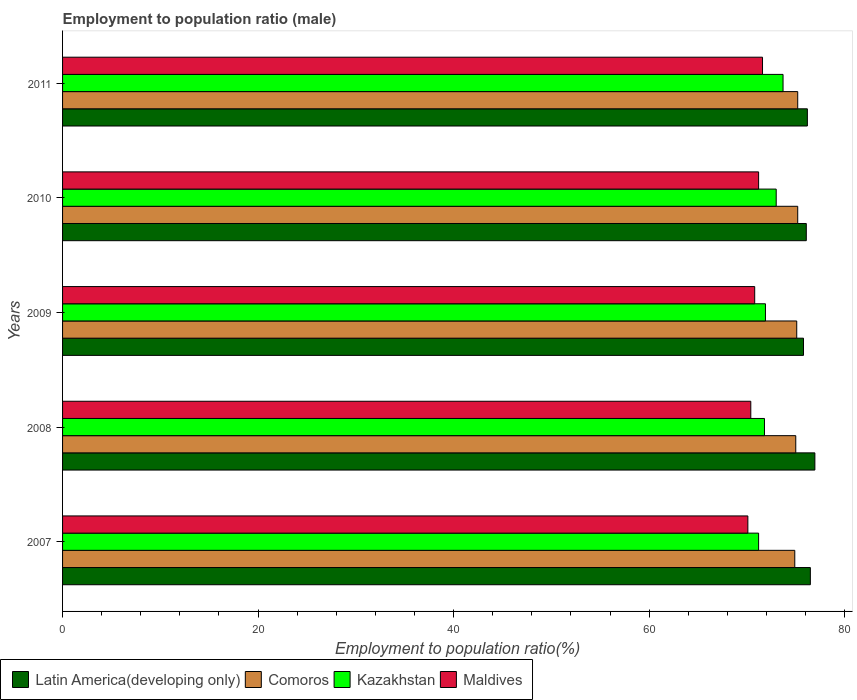How many different coloured bars are there?
Your response must be concise. 4. How many groups of bars are there?
Your response must be concise. 5. Are the number of bars per tick equal to the number of legend labels?
Provide a succinct answer. Yes. Are the number of bars on each tick of the Y-axis equal?
Provide a short and direct response. Yes. How many bars are there on the 5th tick from the top?
Provide a succinct answer. 4. What is the label of the 1st group of bars from the top?
Provide a succinct answer. 2011. In how many cases, is the number of bars for a given year not equal to the number of legend labels?
Provide a succinct answer. 0. What is the employment to population ratio in Maldives in 2008?
Offer a terse response. 70.4. Across all years, what is the maximum employment to population ratio in Kazakhstan?
Keep it short and to the point. 73.7. Across all years, what is the minimum employment to population ratio in Kazakhstan?
Make the answer very short. 71.2. In which year was the employment to population ratio in Maldives minimum?
Ensure brevity in your answer.  2007. What is the total employment to population ratio in Latin America(developing only) in the graph?
Your answer should be very brief. 381.51. What is the difference between the employment to population ratio in Comoros in 2008 and that in 2010?
Provide a short and direct response. -0.2. What is the difference between the employment to population ratio in Latin America(developing only) in 2011 and the employment to population ratio in Comoros in 2007?
Keep it short and to the point. 1.29. What is the average employment to population ratio in Kazakhstan per year?
Your response must be concise. 72.32. In the year 2009, what is the difference between the employment to population ratio in Comoros and employment to population ratio in Maldives?
Your response must be concise. 4.3. What is the ratio of the employment to population ratio in Comoros in 2008 to that in 2010?
Make the answer very short. 1. Is the difference between the employment to population ratio in Comoros in 2007 and 2009 greater than the difference between the employment to population ratio in Maldives in 2007 and 2009?
Provide a short and direct response. Yes. What is the difference between the highest and the second highest employment to population ratio in Latin America(developing only)?
Ensure brevity in your answer.  0.46. In how many years, is the employment to population ratio in Latin America(developing only) greater than the average employment to population ratio in Latin America(developing only) taken over all years?
Provide a succinct answer. 2. Is the sum of the employment to population ratio in Kazakhstan in 2008 and 2011 greater than the maximum employment to population ratio in Comoros across all years?
Your answer should be very brief. Yes. What does the 4th bar from the top in 2007 represents?
Give a very brief answer. Latin America(developing only). What does the 1st bar from the bottom in 2008 represents?
Offer a terse response. Latin America(developing only). Is it the case that in every year, the sum of the employment to population ratio in Kazakhstan and employment to population ratio in Comoros is greater than the employment to population ratio in Latin America(developing only)?
Your response must be concise. Yes. Are all the bars in the graph horizontal?
Provide a succinct answer. Yes. What is the difference between two consecutive major ticks on the X-axis?
Provide a short and direct response. 20. Are the values on the major ticks of X-axis written in scientific E-notation?
Your answer should be compact. No. Does the graph contain any zero values?
Provide a short and direct response. No. What is the title of the graph?
Provide a short and direct response. Employment to population ratio (male). Does "New Caledonia" appear as one of the legend labels in the graph?
Offer a very short reply. No. What is the label or title of the Y-axis?
Offer a terse response. Years. What is the Employment to population ratio(%) of Latin America(developing only) in 2007?
Your answer should be compact. 76.49. What is the Employment to population ratio(%) of Comoros in 2007?
Offer a very short reply. 74.9. What is the Employment to population ratio(%) in Kazakhstan in 2007?
Make the answer very short. 71.2. What is the Employment to population ratio(%) in Maldives in 2007?
Keep it short and to the point. 70.1. What is the Employment to population ratio(%) in Latin America(developing only) in 2008?
Ensure brevity in your answer.  76.96. What is the Employment to population ratio(%) of Comoros in 2008?
Offer a very short reply. 75. What is the Employment to population ratio(%) of Kazakhstan in 2008?
Offer a very short reply. 71.8. What is the Employment to population ratio(%) of Maldives in 2008?
Give a very brief answer. 70.4. What is the Employment to population ratio(%) in Latin America(developing only) in 2009?
Your response must be concise. 75.79. What is the Employment to population ratio(%) in Comoros in 2009?
Give a very brief answer. 75.1. What is the Employment to population ratio(%) of Kazakhstan in 2009?
Your response must be concise. 71.9. What is the Employment to population ratio(%) of Maldives in 2009?
Keep it short and to the point. 70.8. What is the Employment to population ratio(%) of Latin America(developing only) in 2010?
Provide a short and direct response. 76.08. What is the Employment to population ratio(%) in Comoros in 2010?
Offer a very short reply. 75.2. What is the Employment to population ratio(%) in Kazakhstan in 2010?
Your answer should be compact. 73. What is the Employment to population ratio(%) in Maldives in 2010?
Ensure brevity in your answer.  71.2. What is the Employment to population ratio(%) of Latin America(developing only) in 2011?
Provide a succinct answer. 76.19. What is the Employment to population ratio(%) of Comoros in 2011?
Your answer should be compact. 75.2. What is the Employment to population ratio(%) of Kazakhstan in 2011?
Make the answer very short. 73.7. What is the Employment to population ratio(%) of Maldives in 2011?
Offer a terse response. 71.6. Across all years, what is the maximum Employment to population ratio(%) in Latin America(developing only)?
Offer a terse response. 76.96. Across all years, what is the maximum Employment to population ratio(%) of Comoros?
Ensure brevity in your answer.  75.2. Across all years, what is the maximum Employment to population ratio(%) of Kazakhstan?
Keep it short and to the point. 73.7. Across all years, what is the maximum Employment to population ratio(%) of Maldives?
Make the answer very short. 71.6. Across all years, what is the minimum Employment to population ratio(%) in Latin America(developing only)?
Keep it short and to the point. 75.79. Across all years, what is the minimum Employment to population ratio(%) of Comoros?
Offer a terse response. 74.9. Across all years, what is the minimum Employment to population ratio(%) of Kazakhstan?
Your answer should be very brief. 71.2. Across all years, what is the minimum Employment to population ratio(%) in Maldives?
Your response must be concise. 70.1. What is the total Employment to population ratio(%) in Latin America(developing only) in the graph?
Your answer should be very brief. 381.51. What is the total Employment to population ratio(%) of Comoros in the graph?
Offer a very short reply. 375.4. What is the total Employment to population ratio(%) in Kazakhstan in the graph?
Give a very brief answer. 361.6. What is the total Employment to population ratio(%) in Maldives in the graph?
Make the answer very short. 354.1. What is the difference between the Employment to population ratio(%) of Latin America(developing only) in 2007 and that in 2008?
Provide a succinct answer. -0.46. What is the difference between the Employment to population ratio(%) of Comoros in 2007 and that in 2008?
Your answer should be compact. -0.1. What is the difference between the Employment to population ratio(%) in Maldives in 2007 and that in 2008?
Your answer should be compact. -0.3. What is the difference between the Employment to population ratio(%) of Latin America(developing only) in 2007 and that in 2009?
Your response must be concise. 0.7. What is the difference between the Employment to population ratio(%) of Kazakhstan in 2007 and that in 2009?
Ensure brevity in your answer.  -0.7. What is the difference between the Employment to population ratio(%) of Maldives in 2007 and that in 2009?
Your response must be concise. -0.7. What is the difference between the Employment to population ratio(%) in Latin America(developing only) in 2007 and that in 2010?
Your answer should be compact. 0.41. What is the difference between the Employment to population ratio(%) in Kazakhstan in 2007 and that in 2010?
Provide a succinct answer. -1.8. What is the difference between the Employment to population ratio(%) in Latin America(developing only) in 2007 and that in 2011?
Your response must be concise. 0.3. What is the difference between the Employment to population ratio(%) of Kazakhstan in 2007 and that in 2011?
Ensure brevity in your answer.  -2.5. What is the difference between the Employment to population ratio(%) in Maldives in 2007 and that in 2011?
Keep it short and to the point. -1.5. What is the difference between the Employment to population ratio(%) in Latin America(developing only) in 2008 and that in 2009?
Keep it short and to the point. 1.16. What is the difference between the Employment to population ratio(%) in Kazakhstan in 2008 and that in 2009?
Offer a very short reply. -0.1. What is the difference between the Employment to population ratio(%) of Latin America(developing only) in 2008 and that in 2010?
Make the answer very short. 0.88. What is the difference between the Employment to population ratio(%) of Maldives in 2008 and that in 2010?
Provide a succinct answer. -0.8. What is the difference between the Employment to population ratio(%) of Latin America(developing only) in 2008 and that in 2011?
Provide a short and direct response. 0.77. What is the difference between the Employment to population ratio(%) in Comoros in 2008 and that in 2011?
Offer a very short reply. -0.2. What is the difference between the Employment to population ratio(%) of Kazakhstan in 2008 and that in 2011?
Provide a short and direct response. -1.9. What is the difference between the Employment to population ratio(%) in Maldives in 2008 and that in 2011?
Provide a succinct answer. -1.2. What is the difference between the Employment to population ratio(%) of Latin America(developing only) in 2009 and that in 2010?
Your response must be concise. -0.29. What is the difference between the Employment to population ratio(%) of Latin America(developing only) in 2009 and that in 2011?
Offer a very short reply. -0.4. What is the difference between the Employment to population ratio(%) in Comoros in 2009 and that in 2011?
Keep it short and to the point. -0.1. What is the difference between the Employment to population ratio(%) of Kazakhstan in 2009 and that in 2011?
Your response must be concise. -1.8. What is the difference between the Employment to population ratio(%) of Latin America(developing only) in 2010 and that in 2011?
Your answer should be very brief. -0.11. What is the difference between the Employment to population ratio(%) in Latin America(developing only) in 2007 and the Employment to population ratio(%) in Comoros in 2008?
Offer a very short reply. 1.49. What is the difference between the Employment to population ratio(%) in Latin America(developing only) in 2007 and the Employment to population ratio(%) in Kazakhstan in 2008?
Provide a succinct answer. 4.69. What is the difference between the Employment to population ratio(%) of Latin America(developing only) in 2007 and the Employment to population ratio(%) of Maldives in 2008?
Offer a terse response. 6.09. What is the difference between the Employment to population ratio(%) in Comoros in 2007 and the Employment to population ratio(%) in Kazakhstan in 2008?
Give a very brief answer. 3.1. What is the difference between the Employment to population ratio(%) of Comoros in 2007 and the Employment to population ratio(%) of Maldives in 2008?
Provide a short and direct response. 4.5. What is the difference between the Employment to population ratio(%) of Latin America(developing only) in 2007 and the Employment to population ratio(%) of Comoros in 2009?
Offer a very short reply. 1.39. What is the difference between the Employment to population ratio(%) in Latin America(developing only) in 2007 and the Employment to population ratio(%) in Kazakhstan in 2009?
Your response must be concise. 4.59. What is the difference between the Employment to population ratio(%) in Latin America(developing only) in 2007 and the Employment to population ratio(%) in Maldives in 2009?
Offer a terse response. 5.69. What is the difference between the Employment to population ratio(%) in Comoros in 2007 and the Employment to population ratio(%) in Maldives in 2009?
Your answer should be very brief. 4.1. What is the difference between the Employment to population ratio(%) of Latin America(developing only) in 2007 and the Employment to population ratio(%) of Comoros in 2010?
Offer a very short reply. 1.29. What is the difference between the Employment to population ratio(%) in Latin America(developing only) in 2007 and the Employment to population ratio(%) in Kazakhstan in 2010?
Your answer should be very brief. 3.49. What is the difference between the Employment to population ratio(%) of Latin America(developing only) in 2007 and the Employment to population ratio(%) of Maldives in 2010?
Give a very brief answer. 5.29. What is the difference between the Employment to population ratio(%) in Kazakhstan in 2007 and the Employment to population ratio(%) in Maldives in 2010?
Offer a terse response. 0. What is the difference between the Employment to population ratio(%) in Latin America(developing only) in 2007 and the Employment to population ratio(%) in Comoros in 2011?
Make the answer very short. 1.29. What is the difference between the Employment to population ratio(%) in Latin America(developing only) in 2007 and the Employment to population ratio(%) in Kazakhstan in 2011?
Ensure brevity in your answer.  2.79. What is the difference between the Employment to population ratio(%) in Latin America(developing only) in 2007 and the Employment to population ratio(%) in Maldives in 2011?
Make the answer very short. 4.89. What is the difference between the Employment to population ratio(%) in Kazakhstan in 2007 and the Employment to population ratio(%) in Maldives in 2011?
Ensure brevity in your answer.  -0.4. What is the difference between the Employment to population ratio(%) in Latin America(developing only) in 2008 and the Employment to population ratio(%) in Comoros in 2009?
Keep it short and to the point. 1.86. What is the difference between the Employment to population ratio(%) in Latin America(developing only) in 2008 and the Employment to population ratio(%) in Kazakhstan in 2009?
Your answer should be compact. 5.06. What is the difference between the Employment to population ratio(%) of Latin America(developing only) in 2008 and the Employment to population ratio(%) of Maldives in 2009?
Offer a very short reply. 6.16. What is the difference between the Employment to population ratio(%) of Comoros in 2008 and the Employment to population ratio(%) of Kazakhstan in 2009?
Offer a very short reply. 3.1. What is the difference between the Employment to population ratio(%) of Kazakhstan in 2008 and the Employment to population ratio(%) of Maldives in 2009?
Provide a succinct answer. 1. What is the difference between the Employment to population ratio(%) of Latin America(developing only) in 2008 and the Employment to population ratio(%) of Comoros in 2010?
Provide a short and direct response. 1.76. What is the difference between the Employment to population ratio(%) of Latin America(developing only) in 2008 and the Employment to population ratio(%) of Kazakhstan in 2010?
Your response must be concise. 3.96. What is the difference between the Employment to population ratio(%) of Latin America(developing only) in 2008 and the Employment to population ratio(%) of Maldives in 2010?
Offer a terse response. 5.76. What is the difference between the Employment to population ratio(%) of Comoros in 2008 and the Employment to population ratio(%) of Maldives in 2010?
Ensure brevity in your answer.  3.8. What is the difference between the Employment to population ratio(%) in Latin America(developing only) in 2008 and the Employment to population ratio(%) in Comoros in 2011?
Offer a very short reply. 1.76. What is the difference between the Employment to population ratio(%) in Latin America(developing only) in 2008 and the Employment to population ratio(%) in Kazakhstan in 2011?
Provide a short and direct response. 3.26. What is the difference between the Employment to population ratio(%) of Latin America(developing only) in 2008 and the Employment to population ratio(%) of Maldives in 2011?
Give a very brief answer. 5.36. What is the difference between the Employment to population ratio(%) in Comoros in 2008 and the Employment to population ratio(%) in Maldives in 2011?
Your answer should be very brief. 3.4. What is the difference between the Employment to population ratio(%) in Latin America(developing only) in 2009 and the Employment to population ratio(%) in Comoros in 2010?
Your answer should be compact. 0.59. What is the difference between the Employment to population ratio(%) in Latin America(developing only) in 2009 and the Employment to population ratio(%) in Kazakhstan in 2010?
Keep it short and to the point. 2.79. What is the difference between the Employment to population ratio(%) in Latin America(developing only) in 2009 and the Employment to population ratio(%) in Maldives in 2010?
Offer a terse response. 4.59. What is the difference between the Employment to population ratio(%) of Comoros in 2009 and the Employment to population ratio(%) of Kazakhstan in 2010?
Your answer should be very brief. 2.1. What is the difference between the Employment to population ratio(%) of Kazakhstan in 2009 and the Employment to population ratio(%) of Maldives in 2010?
Keep it short and to the point. 0.7. What is the difference between the Employment to population ratio(%) in Latin America(developing only) in 2009 and the Employment to population ratio(%) in Comoros in 2011?
Your response must be concise. 0.59. What is the difference between the Employment to population ratio(%) in Latin America(developing only) in 2009 and the Employment to population ratio(%) in Kazakhstan in 2011?
Your answer should be very brief. 2.09. What is the difference between the Employment to population ratio(%) in Latin America(developing only) in 2009 and the Employment to population ratio(%) in Maldives in 2011?
Keep it short and to the point. 4.19. What is the difference between the Employment to population ratio(%) of Kazakhstan in 2009 and the Employment to population ratio(%) of Maldives in 2011?
Provide a succinct answer. 0.3. What is the difference between the Employment to population ratio(%) in Latin America(developing only) in 2010 and the Employment to population ratio(%) in Comoros in 2011?
Offer a terse response. 0.88. What is the difference between the Employment to population ratio(%) of Latin America(developing only) in 2010 and the Employment to population ratio(%) of Kazakhstan in 2011?
Ensure brevity in your answer.  2.38. What is the difference between the Employment to population ratio(%) of Latin America(developing only) in 2010 and the Employment to population ratio(%) of Maldives in 2011?
Provide a short and direct response. 4.48. What is the difference between the Employment to population ratio(%) of Comoros in 2010 and the Employment to population ratio(%) of Maldives in 2011?
Your response must be concise. 3.6. What is the average Employment to population ratio(%) of Latin America(developing only) per year?
Keep it short and to the point. 76.3. What is the average Employment to population ratio(%) of Comoros per year?
Your answer should be compact. 75.08. What is the average Employment to population ratio(%) of Kazakhstan per year?
Provide a short and direct response. 72.32. What is the average Employment to population ratio(%) in Maldives per year?
Provide a short and direct response. 70.82. In the year 2007, what is the difference between the Employment to population ratio(%) of Latin America(developing only) and Employment to population ratio(%) of Comoros?
Ensure brevity in your answer.  1.59. In the year 2007, what is the difference between the Employment to population ratio(%) in Latin America(developing only) and Employment to population ratio(%) in Kazakhstan?
Offer a terse response. 5.29. In the year 2007, what is the difference between the Employment to population ratio(%) in Latin America(developing only) and Employment to population ratio(%) in Maldives?
Your answer should be compact. 6.39. In the year 2007, what is the difference between the Employment to population ratio(%) of Comoros and Employment to population ratio(%) of Kazakhstan?
Offer a terse response. 3.7. In the year 2008, what is the difference between the Employment to population ratio(%) in Latin America(developing only) and Employment to population ratio(%) in Comoros?
Your response must be concise. 1.96. In the year 2008, what is the difference between the Employment to population ratio(%) of Latin America(developing only) and Employment to population ratio(%) of Kazakhstan?
Ensure brevity in your answer.  5.16. In the year 2008, what is the difference between the Employment to population ratio(%) of Latin America(developing only) and Employment to population ratio(%) of Maldives?
Provide a short and direct response. 6.56. In the year 2008, what is the difference between the Employment to population ratio(%) in Comoros and Employment to population ratio(%) in Kazakhstan?
Keep it short and to the point. 3.2. In the year 2008, what is the difference between the Employment to population ratio(%) of Kazakhstan and Employment to population ratio(%) of Maldives?
Offer a very short reply. 1.4. In the year 2009, what is the difference between the Employment to population ratio(%) in Latin America(developing only) and Employment to population ratio(%) in Comoros?
Your response must be concise. 0.69. In the year 2009, what is the difference between the Employment to population ratio(%) in Latin America(developing only) and Employment to population ratio(%) in Kazakhstan?
Offer a terse response. 3.89. In the year 2009, what is the difference between the Employment to population ratio(%) in Latin America(developing only) and Employment to population ratio(%) in Maldives?
Ensure brevity in your answer.  4.99. In the year 2009, what is the difference between the Employment to population ratio(%) of Comoros and Employment to population ratio(%) of Maldives?
Provide a short and direct response. 4.3. In the year 2009, what is the difference between the Employment to population ratio(%) of Kazakhstan and Employment to population ratio(%) of Maldives?
Ensure brevity in your answer.  1.1. In the year 2010, what is the difference between the Employment to population ratio(%) in Latin America(developing only) and Employment to population ratio(%) in Comoros?
Your answer should be very brief. 0.88. In the year 2010, what is the difference between the Employment to population ratio(%) in Latin America(developing only) and Employment to population ratio(%) in Kazakhstan?
Provide a succinct answer. 3.08. In the year 2010, what is the difference between the Employment to population ratio(%) of Latin America(developing only) and Employment to population ratio(%) of Maldives?
Make the answer very short. 4.88. In the year 2010, what is the difference between the Employment to population ratio(%) in Comoros and Employment to population ratio(%) in Kazakhstan?
Offer a very short reply. 2.2. In the year 2010, what is the difference between the Employment to population ratio(%) in Comoros and Employment to population ratio(%) in Maldives?
Provide a succinct answer. 4. In the year 2010, what is the difference between the Employment to population ratio(%) in Kazakhstan and Employment to population ratio(%) in Maldives?
Provide a short and direct response. 1.8. In the year 2011, what is the difference between the Employment to population ratio(%) in Latin America(developing only) and Employment to population ratio(%) in Comoros?
Your response must be concise. 0.99. In the year 2011, what is the difference between the Employment to population ratio(%) in Latin America(developing only) and Employment to population ratio(%) in Kazakhstan?
Keep it short and to the point. 2.49. In the year 2011, what is the difference between the Employment to population ratio(%) of Latin America(developing only) and Employment to population ratio(%) of Maldives?
Your answer should be very brief. 4.59. In the year 2011, what is the difference between the Employment to population ratio(%) of Comoros and Employment to population ratio(%) of Maldives?
Give a very brief answer. 3.6. In the year 2011, what is the difference between the Employment to population ratio(%) in Kazakhstan and Employment to population ratio(%) in Maldives?
Ensure brevity in your answer.  2.1. What is the ratio of the Employment to population ratio(%) of Maldives in 2007 to that in 2008?
Provide a short and direct response. 1. What is the ratio of the Employment to population ratio(%) of Latin America(developing only) in 2007 to that in 2009?
Give a very brief answer. 1.01. What is the ratio of the Employment to population ratio(%) in Kazakhstan in 2007 to that in 2009?
Ensure brevity in your answer.  0.99. What is the ratio of the Employment to population ratio(%) in Comoros in 2007 to that in 2010?
Offer a very short reply. 1. What is the ratio of the Employment to population ratio(%) of Kazakhstan in 2007 to that in 2010?
Offer a very short reply. 0.98. What is the ratio of the Employment to population ratio(%) of Maldives in 2007 to that in 2010?
Ensure brevity in your answer.  0.98. What is the ratio of the Employment to population ratio(%) of Comoros in 2007 to that in 2011?
Your answer should be very brief. 1. What is the ratio of the Employment to population ratio(%) in Kazakhstan in 2007 to that in 2011?
Your response must be concise. 0.97. What is the ratio of the Employment to population ratio(%) of Maldives in 2007 to that in 2011?
Provide a succinct answer. 0.98. What is the ratio of the Employment to population ratio(%) in Latin America(developing only) in 2008 to that in 2009?
Make the answer very short. 1.02. What is the ratio of the Employment to population ratio(%) of Kazakhstan in 2008 to that in 2009?
Your answer should be very brief. 1. What is the ratio of the Employment to population ratio(%) of Latin America(developing only) in 2008 to that in 2010?
Provide a succinct answer. 1.01. What is the ratio of the Employment to population ratio(%) in Comoros in 2008 to that in 2010?
Offer a terse response. 1. What is the ratio of the Employment to population ratio(%) of Kazakhstan in 2008 to that in 2010?
Your answer should be very brief. 0.98. What is the ratio of the Employment to population ratio(%) in Latin America(developing only) in 2008 to that in 2011?
Provide a succinct answer. 1.01. What is the ratio of the Employment to population ratio(%) in Kazakhstan in 2008 to that in 2011?
Make the answer very short. 0.97. What is the ratio of the Employment to population ratio(%) in Maldives in 2008 to that in 2011?
Your answer should be compact. 0.98. What is the ratio of the Employment to population ratio(%) in Kazakhstan in 2009 to that in 2010?
Offer a terse response. 0.98. What is the ratio of the Employment to population ratio(%) of Maldives in 2009 to that in 2010?
Keep it short and to the point. 0.99. What is the ratio of the Employment to population ratio(%) of Latin America(developing only) in 2009 to that in 2011?
Your answer should be very brief. 0.99. What is the ratio of the Employment to population ratio(%) of Kazakhstan in 2009 to that in 2011?
Provide a succinct answer. 0.98. What is the ratio of the Employment to population ratio(%) of Kazakhstan in 2010 to that in 2011?
Your response must be concise. 0.99. What is the difference between the highest and the second highest Employment to population ratio(%) of Latin America(developing only)?
Make the answer very short. 0.46. What is the difference between the highest and the second highest Employment to population ratio(%) of Comoros?
Offer a very short reply. 0. What is the difference between the highest and the second highest Employment to population ratio(%) in Kazakhstan?
Your answer should be very brief. 0.7. What is the difference between the highest and the lowest Employment to population ratio(%) of Latin America(developing only)?
Your answer should be compact. 1.16. What is the difference between the highest and the lowest Employment to population ratio(%) in Comoros?
Give a very brief answer. 0.3. What is the difference between the highest and the lowest Employment to population ratio(%) in Kazakhstan?
Your answer should be compact. 2.5. 